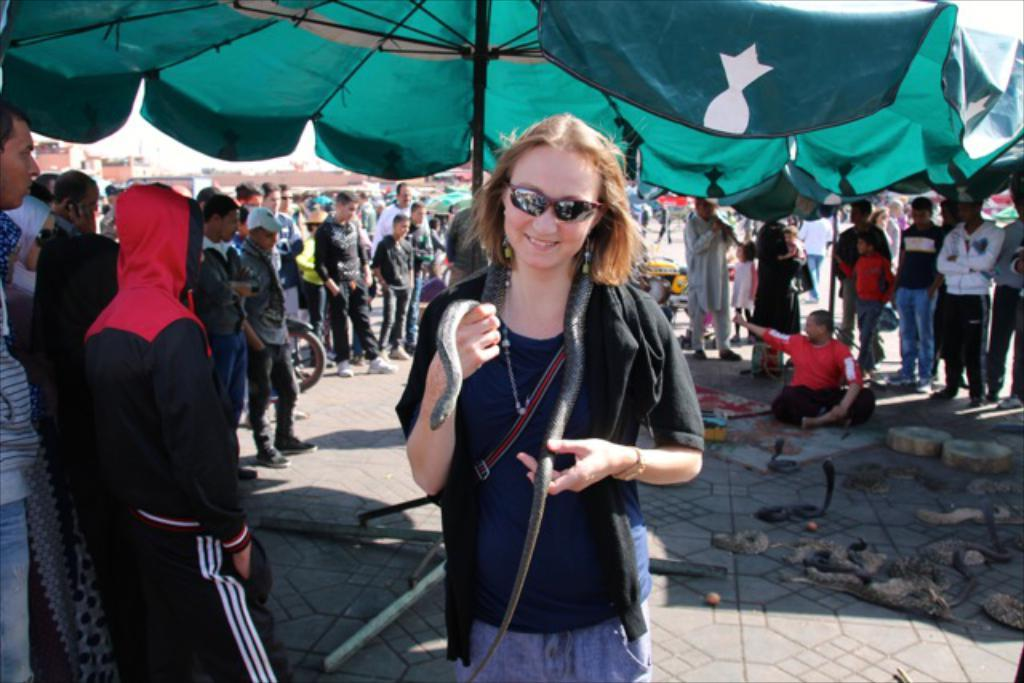Who is the main subject in the image? There is a woman in the image. What is the woman holding in the image? The woman is holding a snake. What is the woman wearing in the image? The woman is wearing a black jacket. How many people are present in the image? There are many persons standing in the image. What else can be seen on the ground in the image? There are snakes on the ground at the bottom of the image. What type of amusement can be seen in the image? There is no amusement present in the image; it features a woman holding a snake and other people standing nearby. How does the growth of the snakes affect the image? There is no growth of snakes mentioned in the image, as it only shows snakes on the ground and a woman holding one. 